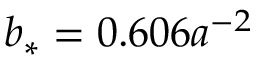<formula> <loc_0><loc_0><loc_500><loc_500>b _ { * } = 0 . 6 0 6 a ^ { - 2 }</formula> 